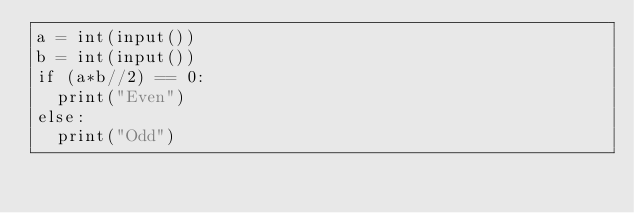<code> <loc_0><loc_0><loc_500><loc_500><_Python_>a = int(input())
b = int(input())
if (a*b//2) == 0:
  print("Even")
else:
  print("Odd")</code> 